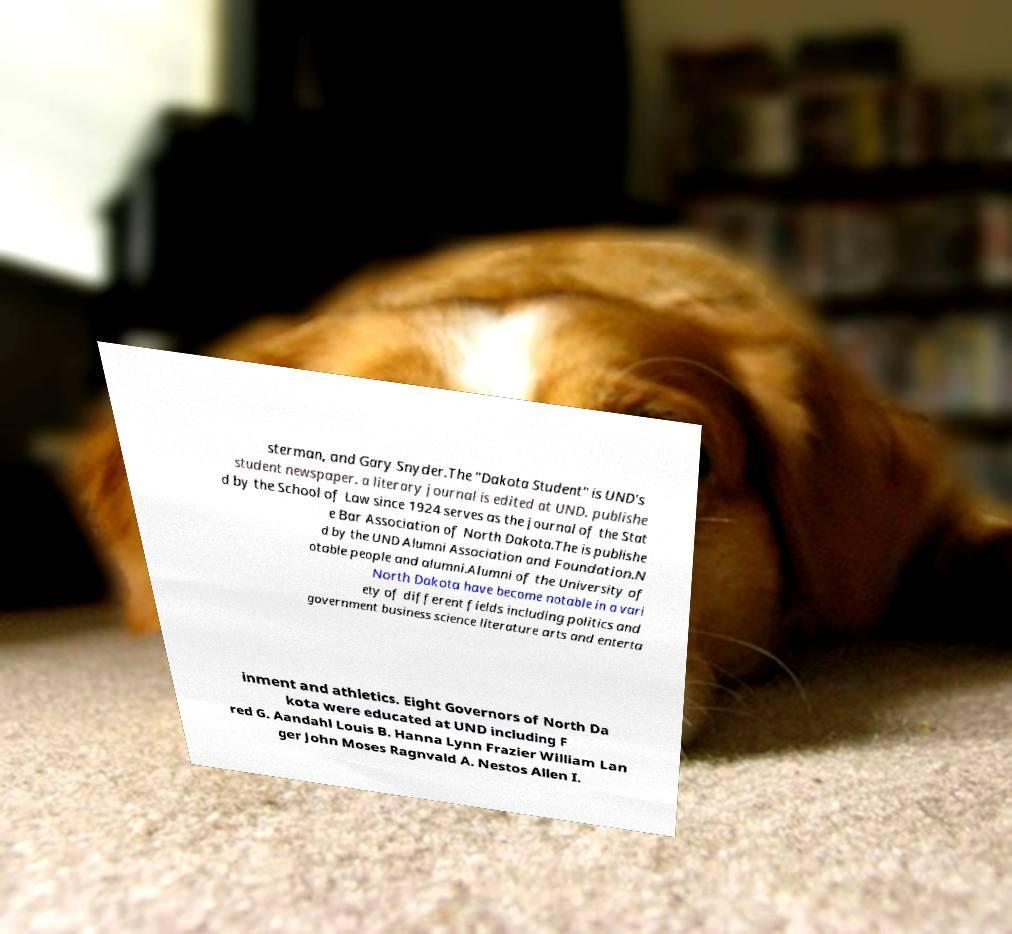Please identify and transcribe the text found in this image. sterman, and Gary Snyder.The "Dakota Student" is UND's student newspaper. a literary journal is edited at UND. publishe d by the School of Law since 1924 serves as the journal of the Stat e Bar Association of North Dakota.The is publishe d by the UND Alumni Association and Foundation.N otable people and alumni.Alumni of the University of North Dakota have become notable in a vari ety of different fields including politics and government business science literature arts and enterta inment and athletics. Eight Governors of North Da kota were educated at UND including F red G. Aandahl Louis B. Hanna Lynn Frazier William Lan ger John Moses Ragnvald A. Nestos Allen I. 